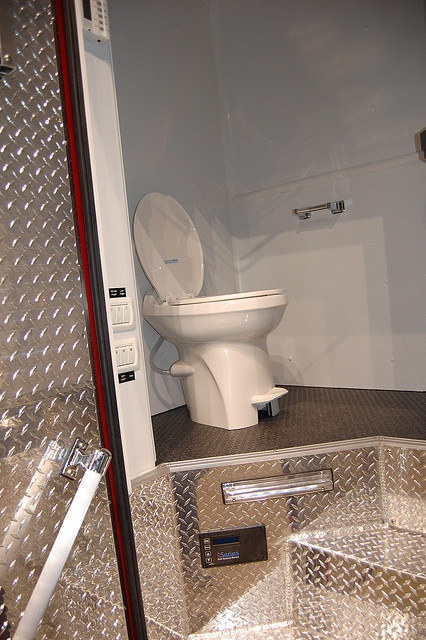Describe the objects in this image and their specific colors. I can see a toilet in black, darkgray, tan, and gray tones in this image. 